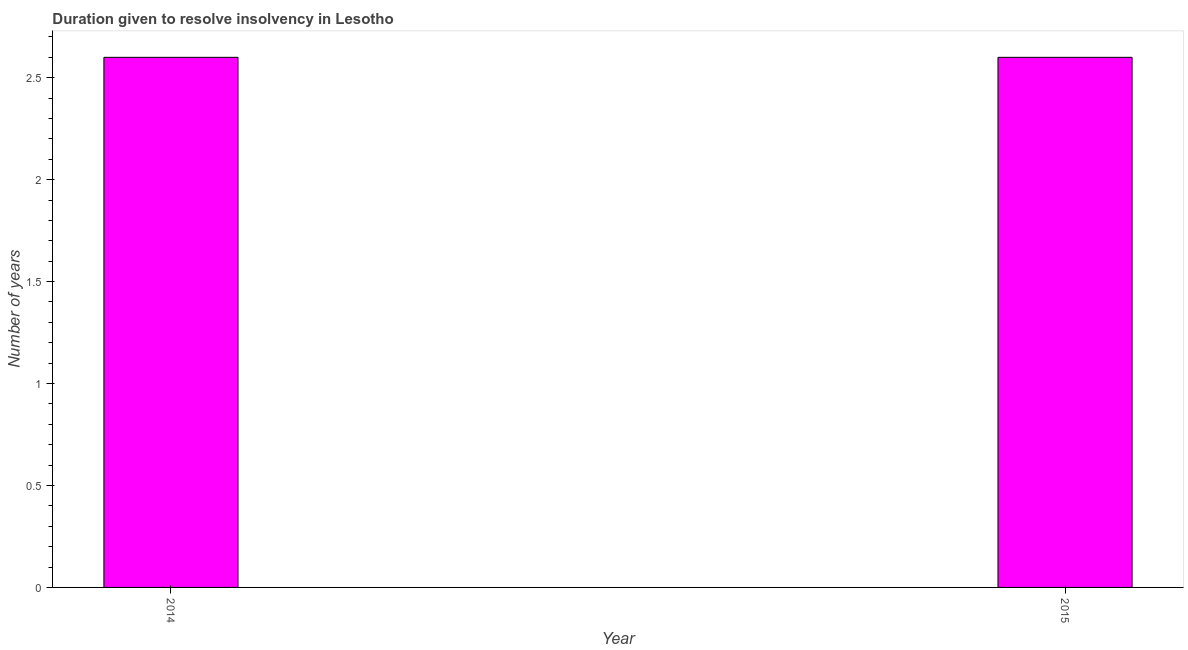What is the title of the graph?
Give a very brief answer. Duration given to resolve insolvency in Lesotho. What is the label or title of the X-axis?
Provide a succinct answer. Year. What is the label or title of the Y-axis?
Make the answer very short. Number of years. What is the number of years to resolve insolvency in 2015?
Your response must be concise. 2.6. In which year was the number of years to resolve insolvency maximum?
Ensure brevity in your answer.  2014. What is the difference between the number of years to resolve insolvency in 2014 and 2015?
Provide a succinct answer. 0. What is the median number of years to resolve insolvency?
Provide a short and direct response. 2.6. In how many years, is the number of years to resolve insolvency greater than 2.5 ?
Provide a short and direct response. 2. Do a majority of the years between 2015 and 2014 (inclusive) have number of years to resolve insolvency greater than 2.6 ?
Your answer should be very brief. No. What is the ratio of the number of years to resolve insolvency in 2014 to that in 2015?
Make the answer very short. 1. In how many years, is the number of years to resolve insolvency greater than the average number of years to resolve insolvency taken over all years?
Make the answer very short. 0. Are the values on the major ticks of Y-axis written in scientific E-notation?
Offer a very short reply. No. What is the Number of years in 2015?
Your answer should be very brief. 2.6. What is the difference between the Number of years in 2014 and 2015?
Offer a very short reply. 0. 